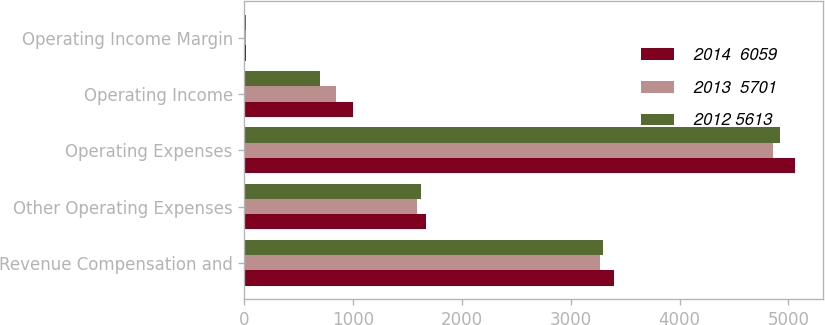Convert chart. <chart><loc_0><loc_0><loc_500><loc_500><stacked_bar_chart><ecel><fcel>Revenue Compensation and<fcel>Other Operating Expenses<fcel>Operating Expenses<fcel>Operating Income<fcel>Operating Income Margin<nl><fcel>2014  6059<fcel>3398<fcel>1665<fcel>5063<fcel>996<fcel>16.4<nl><fcel>2013  5701<fcel>3269<fcel>1587<fcel>4856<fcel>845<fcel>14.8<nl><fcel>2012 5613<fcel>3298<fcel>1623<fcel>4921<fcel>692<fcel>12.3<nl></chart> 